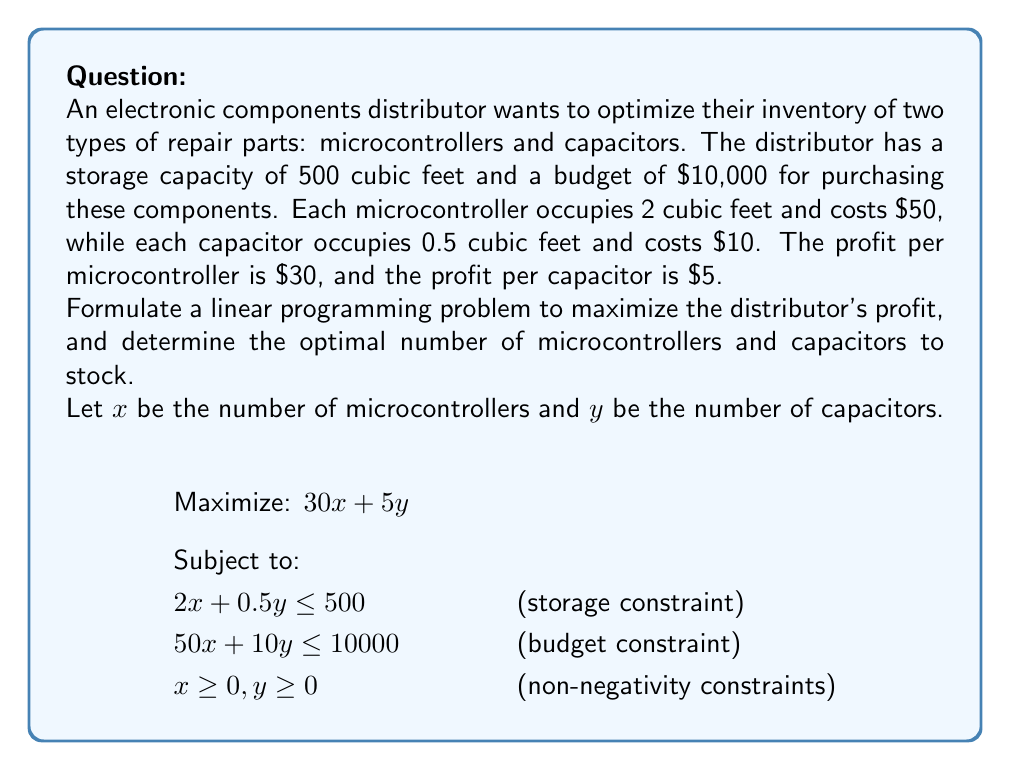Give your solution to this math problem. To solve this linear programming problem, we'll use the graphical method:

1. Plot the constraints:
   - Storage constraint: $2x + 0.5y = 500$
   - Budget constraint: $50x + 10y = 10000$

2. Identify the feasible region:
   The feasible region is the area that satisfies all constraints.

3. Find the corner points of the feasible region:
   a) (0, 0) - origin
   b) (0, 1000) - y-intercept of budget constraint
   c) (0, 1000) - y-intercept of storage constraint
   d) Intersection of storage and budget constraints:
      Solve the system of equations:
      $2x + 0.5y = 500$
      $50x + 10y = 10000$
      
      Multiplying the first equation by 25:
      $50x + 12.5y = 12500$
      $50x + 10y = 10000$
      Subtracting:
      $2.5y = 2500$
      $y = 1000$
      
      Substituting back:
      $2x + 0.5(1000) = 500$
      $2x = 500 - 500 = 0$
      $x = 0$
      
      So, the intersection point is (0, 1000)
   
   e) (200, 0) - x-intercept of storage constraint
   f) (200, 0) - x-intercept of budget constraint

4. Evaluate the objective function at each corner point:
   (0, 0): $30(0) + 5(0) = 0$
   (0, 1000): $30(0) + 5(1000) = 5000$
   (200, 0): $30(200) + 5(0) = 6000$

5. The maximum profit occurs at (200, 0), which corresponds to stocking 200 microcontrollers and 0 capacitors.
Answer: 200 microcontrollers, 0 capacitors 